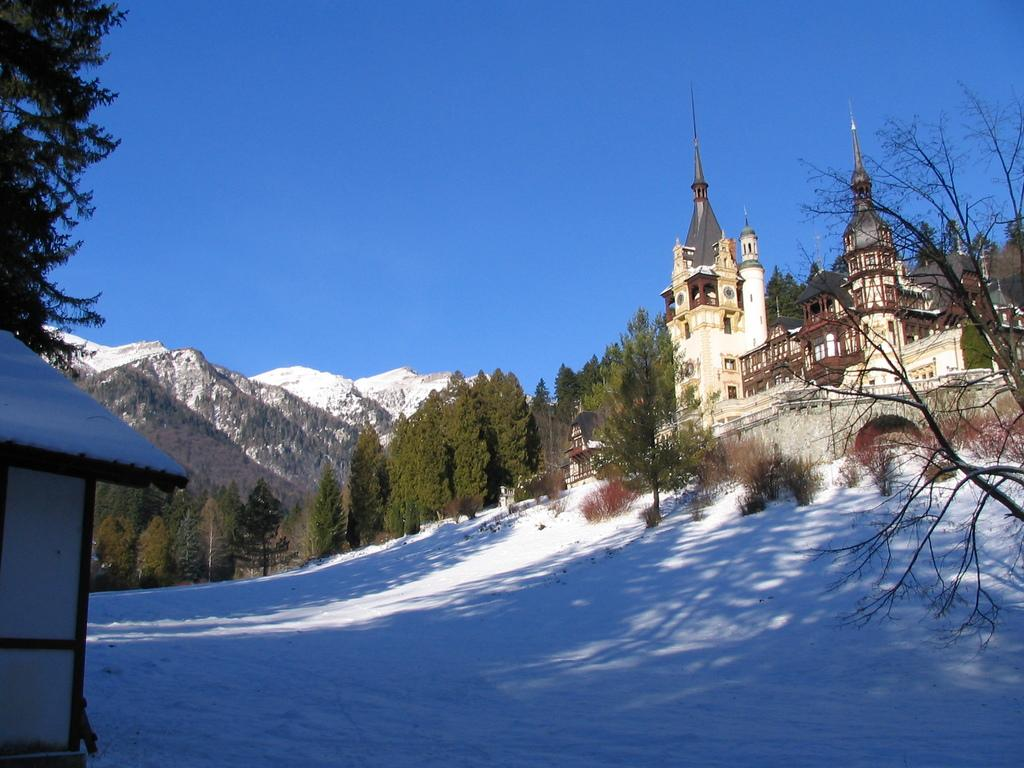What type of structure is present in the image? There is a building in the image. What natural features can be seen in the background? There are mountains in the image. What type of vegetation is present in front of the mountains? There are trees in front of the mountains. What is the condition of the ground in front of the building? Snow is visible on the ground in front of the building. What is the weather like in the image? The sky is clear in the image. What type of property is being tested in the image? There is no indication of any property being tested in the image. What season is depicted in the image? The presence of snow suggests that the image might be depicting winter, but the provided facts do not specifically mention the season. 